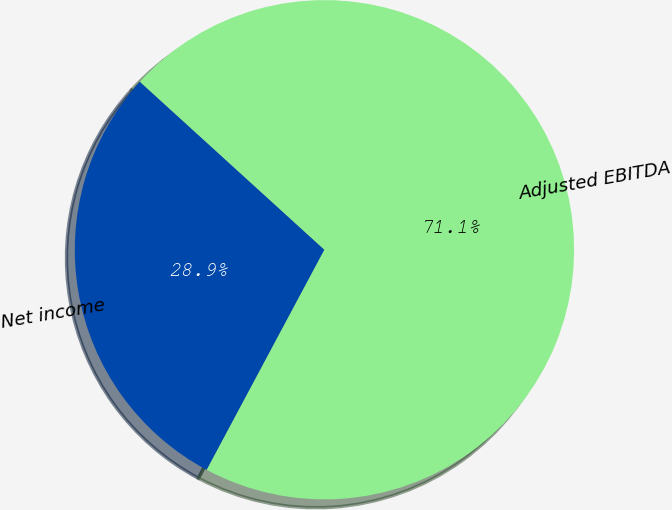Convert chart. <chart><loc_0><loc_0><loc_500><loc_500><pie_chart><fcel>Net income<fcel>Adjusted EBITDA<nl><fcel>28.94%<fcel>71.06%<nl></chart> 